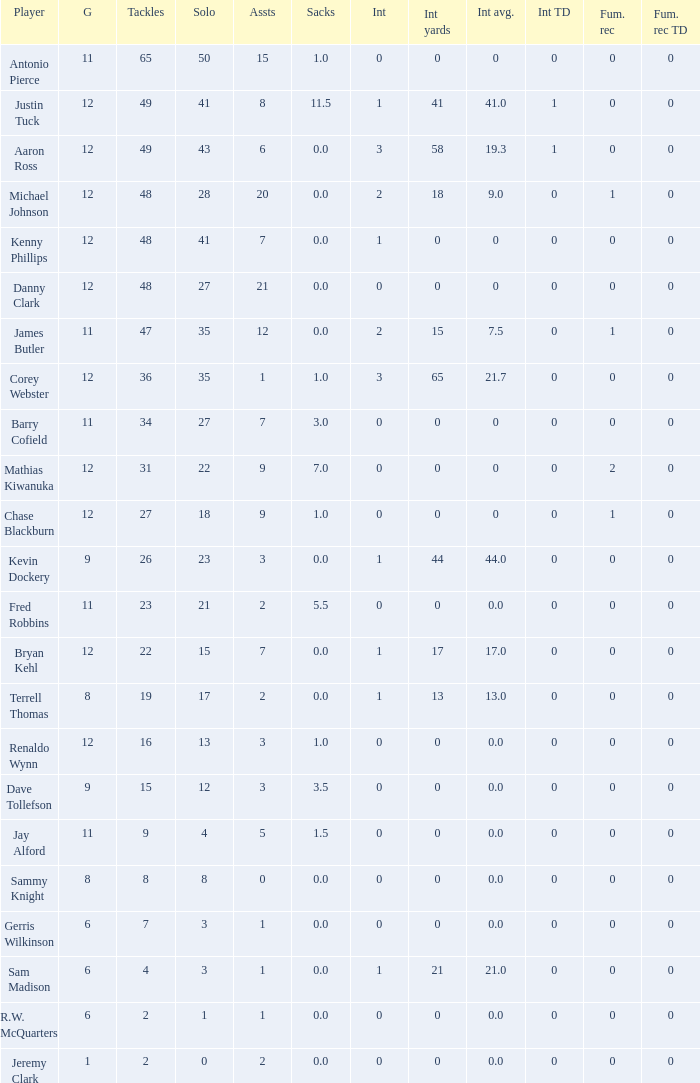Specify the minimal quantity of whole yards. 0.0. 